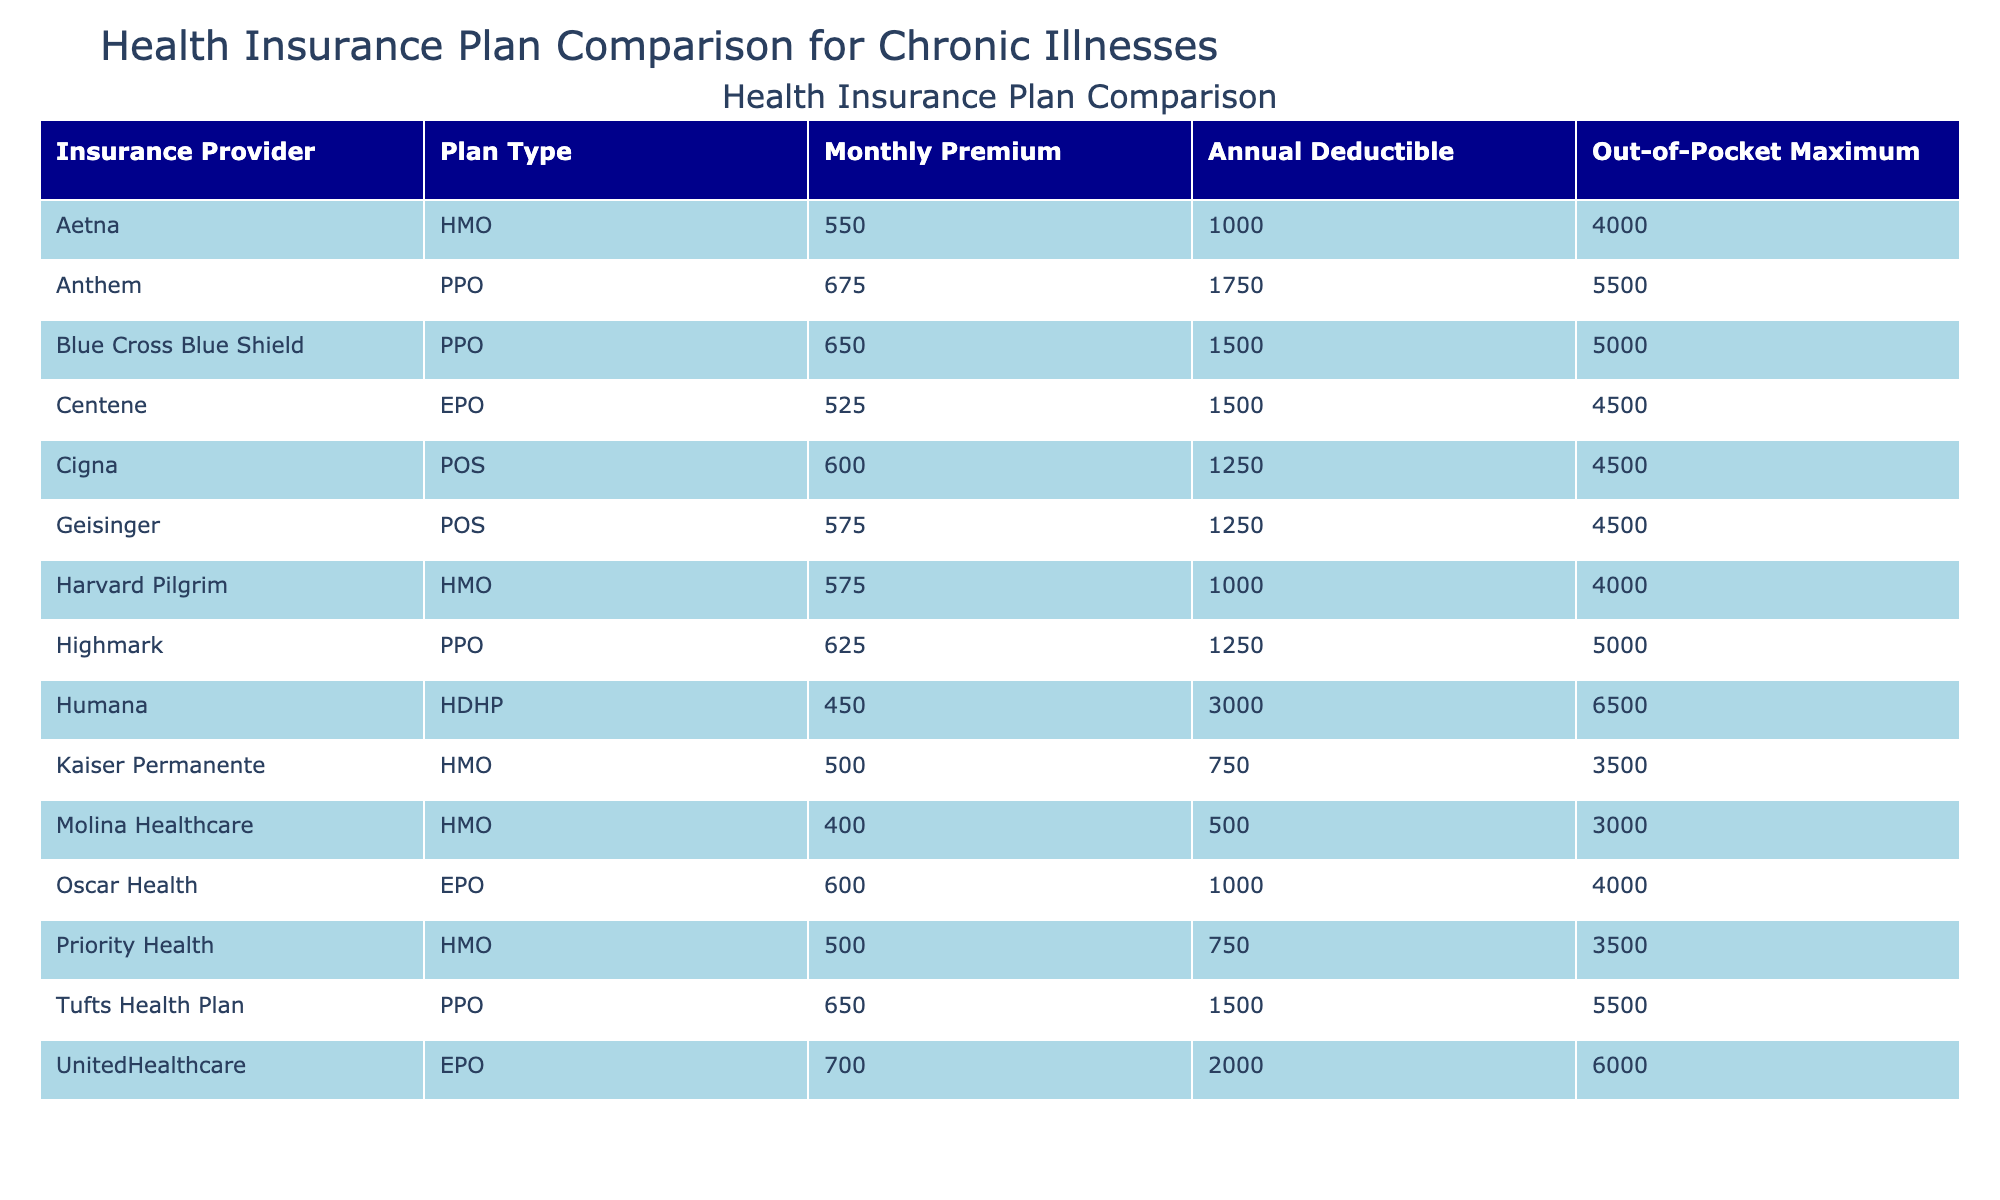What is the monthly premium for the Aetna HMO plan? The table lists Aetna under Insurance Provider and HMO under Plan Type. The corresponding Monthly Premium value for this plan is 550.
Answer: 550 What is the out-of-pocket maximum for the Humana HDHP plan? Looking at the table, we find Humana under Insurance Provider and HDHP under Plan Type, which shows an Out-of-Pocket Maximum of 6500.
Answer: 6500 What is the average annual deductible among all the plans? To calculate the average annual deductible, we sum all the Annual Deductibles (1500, 1000, 2000, 1250, 3000, 750, 1750, 500, 1500, 1000, 1250, 750, 1250) which totals to 16250. There are 13 plans, so the average is 16250/13 = 1250.
Answer: 1250 Is prescription coverage available in the Cigna POS plan? In the table, Cigna is listed under Insurance Provider and POS under Plan Type. The Prescription Coverage column indicates that it is 85%, which means coverage is indeed available.
Answer: Yes Which plan has the lowest monthly premium and what is that amount? To find the lowest monthly premium, we review the Monthly Premium column and identify Molina Healthcare HMO with a premium of 400, which is the smallest value in the list.
Answer: 400 How many plans offer chronic illness support? By checking the Chronic Illness Support column for each plan, we find that 13 plans indicate "Yes". Therefore, there are 13 plans available that offer chronic illness support.
Answer: 13 Which two plans have the same out-of-pocket maximum and what is that maximum? Reviewing the Out-of-Pocket Maximum column, both Kaiser Permanente HMO and Priority Health HMO have an Out-of-Pocket Maximum of 3500. This is a shared value between these two plans.
Answer: 3500 What is the difference in monthly premiums between the most expensive and the cheapest plan? The most expensive plan is UnitedHealthcare EPO at 700 and the cheapest is Molina Healthcare HMO at 400. The difference is calculated as 700 - 400 = 300.
Answer: 300 Is there a plan with a child-specific benefit and an out-of-pocket maximum less than 4000? Upon examining the table, the Kaiser Permanente HMO, Molina Healthcare HMO, and Priority Health HMO all have child-specific benefits and out-of-pocket maximums of 3500, which is indeed less than 4000.
Answer: Yes 